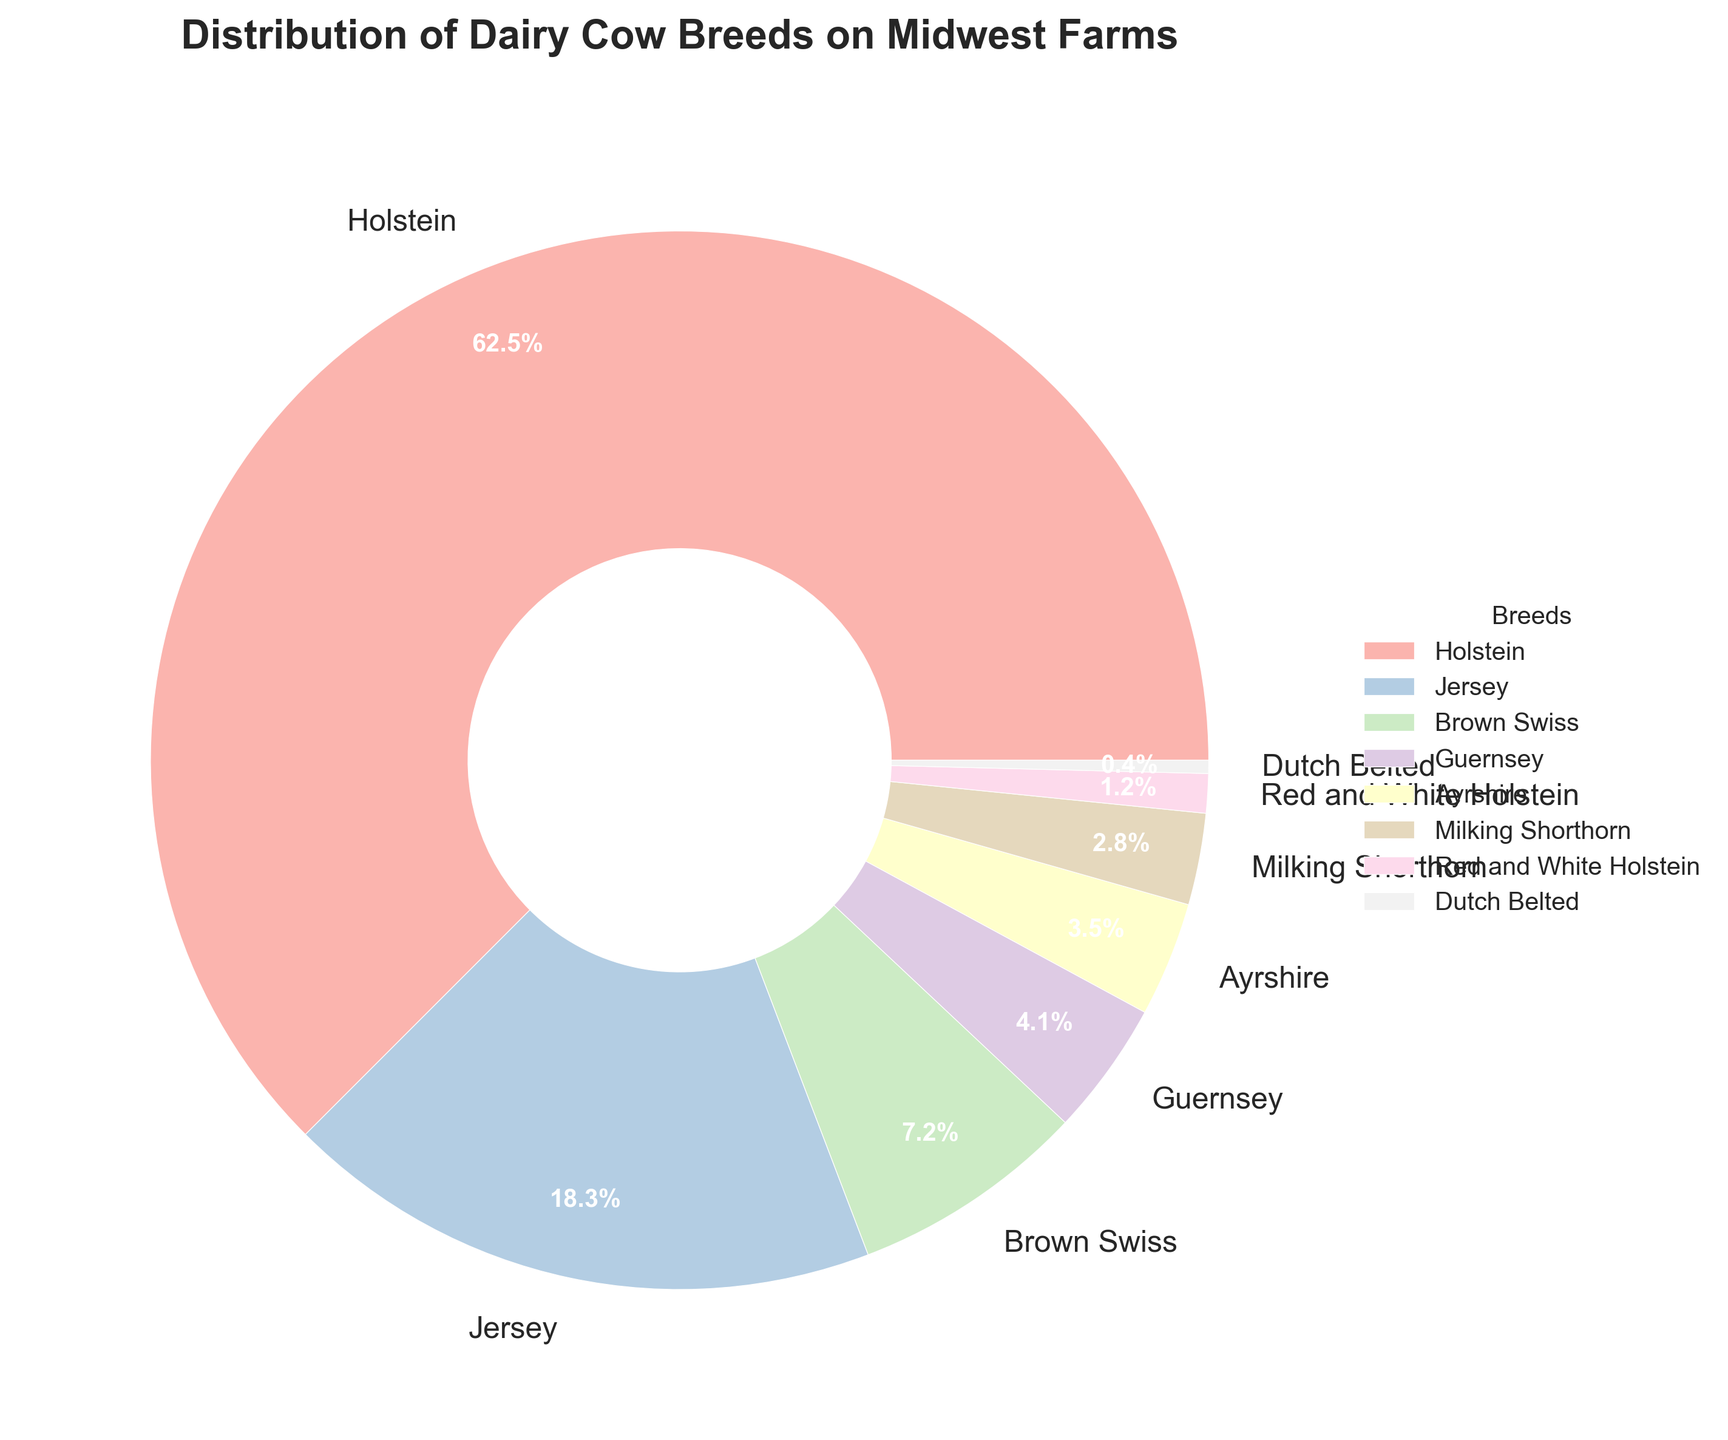What's the most common breed of dairy cow on Midwest farms? By looking at the pie chart, the breed with the largest portion of the pie is the most common. In this case, it is the Holstein breed, which occupies 62.5% of the pie chart.
Answer: Holstein Which breed occupies the second largest portion of the pie chart? Observing the second most notable section of the pie chart, the Jersey breed is the one occupying this portion with 18.3%.
Answer: Jersey How much larger is the percentage of Holsteins compared to Jerseys? The Holsteins make up 62.5% and the Jerseys make up 18.3%. Subtract the Jersey percentage from the Holstein percentage: 62.5% - 18.3% = 44.2%.
Answer: 44.2% Which two breeds combined have a percentage close to 10%? The percentages for Brown Swiss and Guernsey are 7.2% and 4.1% respectively. When combined, 7.2% + 4.1% = 11.3%. However, Ayrshire (3.5%) and Milking Shorthorn (2.8%) combined give 3.5% + 2.8% = 6.3%, and no two other breeds sum up closer to 10%.
Answer: Brown Swiss and Guernsey What breed has only 0.4% of the total distribution? The smallest portion of the pie is represented by Dutch Belted, which shows a distribution of 0.4%.
Answer: Dutch Belted Combine the percentage of all breeds except Holstein and find the total. Total percentage excluding Holstein: 18.3% (Jersey) + 7.2% (Brown Swiss) + 4.1% (Guernsey) + 3.5% (Ayrshire) + 2.8% (Milking Shorthorn) + 1.2% (Red and White Holstein) + 0.4% (Dutch Belted) = 37.5%.
Answer: 37.5% What breeds have nearly equal percentages? The percentages for Ayrshire and Milking Shorthorn are 3.5% and 2.8%, respectively. These percentages are reasonably close to each other.
Answer: Ayrshire and Milking Shorthorn What is the combined percentage of Red and White Holstein and Dutch Belted breeds? Sum the percentages for these breeds: 1.2% (Red and White Holstein) + 0.4% (Dutch Belted) = 1.6%.
Answer: 1.6% 